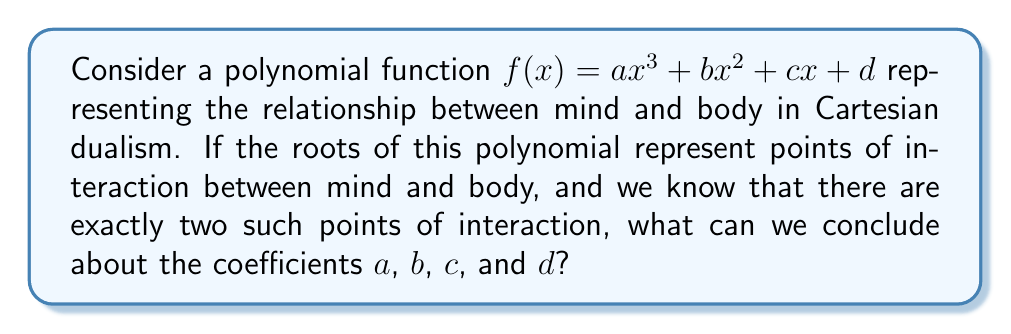Could you help me with this problem? To approach this problem, let's consider the properties of polynomial functions and relate them to the concept of mind-body dualism:

1) In Cartesian dualism, the mind and body are considered separate entities that interact at specific points. These interaction points are represented by the roots of our polynomial.

2) We're told that there are exactly two points of interaction, which means our polynomial has exactly two real roots.

3) For a cubic function ($ax^3 + bx^2 + cx + d$) to have exactly two real roots, it must have:
   - Two distinct real roots
   - One repeated real root (multiplicity of 2)

4) The fundamental theorem of algebra states that a polynomial of degree $n$ has exactly $n$ complex roots (counting multiplicity). Since our polynomial is of degree 3, it must have 3 roots in total.

5) Given points 3 and 4, we can conclude that our polynomial must have:
   - Two distinct real roots
   - One complex root

6) For a cubic function to have this root structure, its graph must cross the x-axis at two points, with one of these crossings being tangential (touching but not crossing).

7) This shape is characteristic of a cubic function with a local maximum or minimum that just touches the x-axis.

8) For this to occur, the discriminant of the polynomial must be equal to zero. The discriminant of a cubic $ax^3 + bx^2 + cx + d$ is given by:

   $$\Delta = 18abcd - 4b^3d + b^2c^2 - 4ac^3 - 27a^2d^2$$

9) Therefore, for our polynomial to represent the mind-body interaction as described, its coefficients $a$, $b$, $c$, and $d$ must satisfy the equation $\Delta = 0$.
Answer: $18abcd - 4b^3d + b^2c^2 - 4ac^3 - 27a^2d^2 = 0$ 